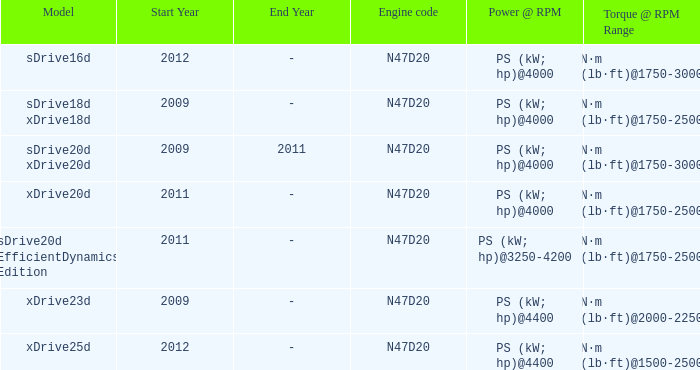What years did the sdrive16d model have a Torque of n·m (lb·ft)@1750-3000? 2012-. Could you parse the entire table as a dict? {'header': ['Model', 'Start Year', 'End Year', 'Engine code', 'Power @ RPM', 'Torque @ RPM Range'], 'rows': [['sDrive16d', '2012', '-', 'N47D20', 'PS (kW; hp)@4000', 'N·m (lb·ft)@1750-3000'], ['sDrive18d xDrive18d', '2009', '-', 'N47D20', 'PS (kW; hp)@4000', 'N·m (lb·ft)@1750-2500'], ['sDrive20d xDrive20d', '2009', '2011', 'N47D20', 'PS (kW; hp)@4000', 'N·m (lb·ft)@1750-3000'], ['xDrive20d', '2011', '-', 'N47D20', 'PS (kW; hp)@4000', 'N·m (lb·ft)@1750-2500'], ['sDrive20d EfficientDynamics Edition', '2011', '-', 'N47D20', 'PS (kW; hp)@3250-4200', 'N·m (lb·ft)@1750-2500'], ['xDrive23d', '2009', '-', 'N47D20', 'PS (kW; hp)@4400', 'N·m (lb·ft)@2000-2250'], ['xDrive25d', '2012', '-', 'N47D20', 'PS (kW; hp)@4400', 'N·m (lb·ft)@1500-2500']]} 